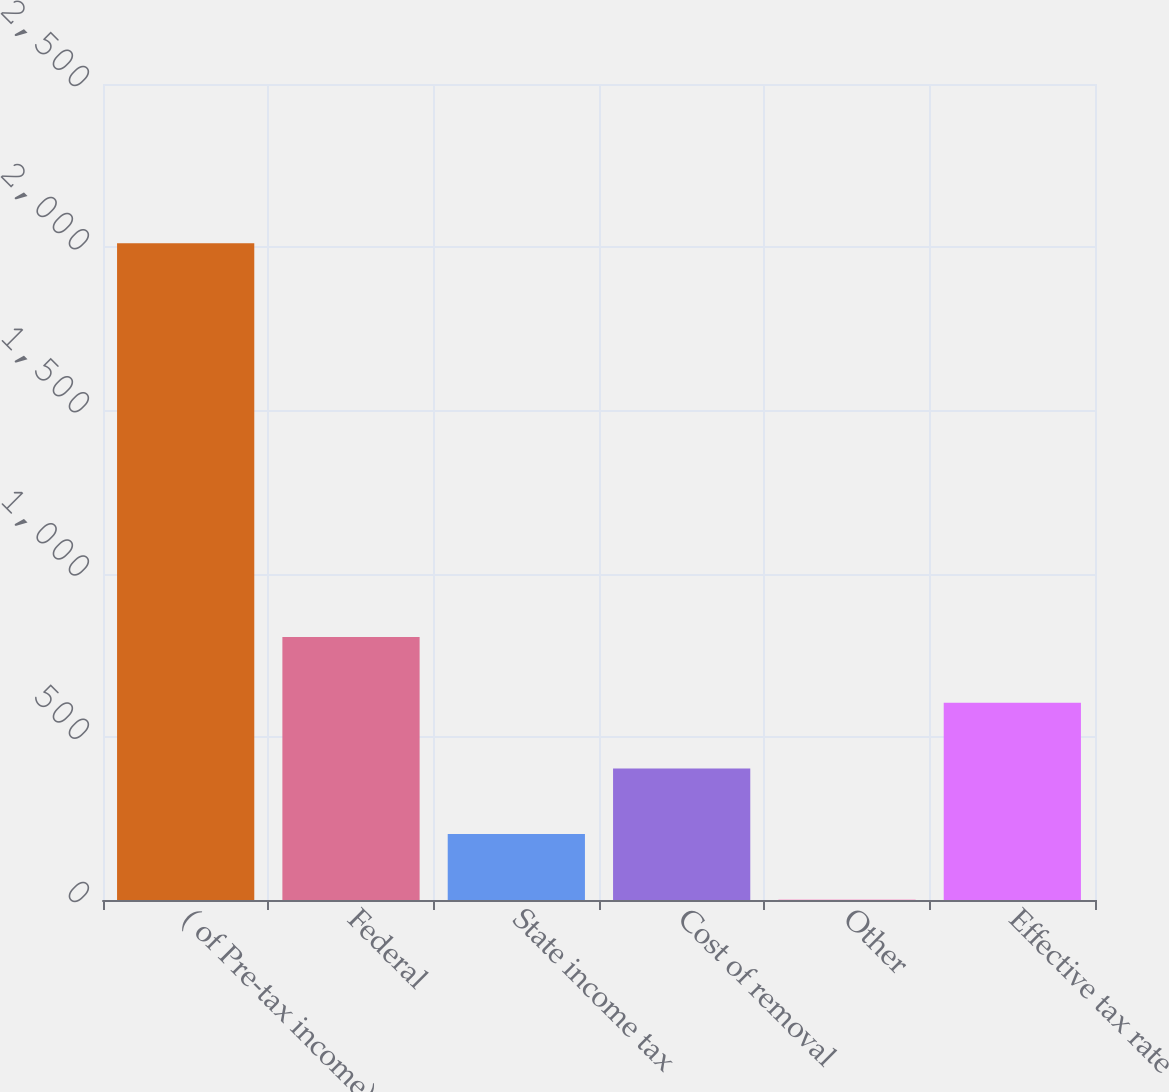Convert chart. <chart><loc_0><loc_0><loc_500><loc_500><bar_chart><fcel>( of Pre-tax income)<fcel>Federal<fcel>State income tax<fcel>Cost of removal<fcel>Other<fcel>Effective tax rate<nl><fcel>2012<fcel>805.4<fcel>202.1<fcel>403.2<fcel>1<fcel>604.3<nl></chart> 